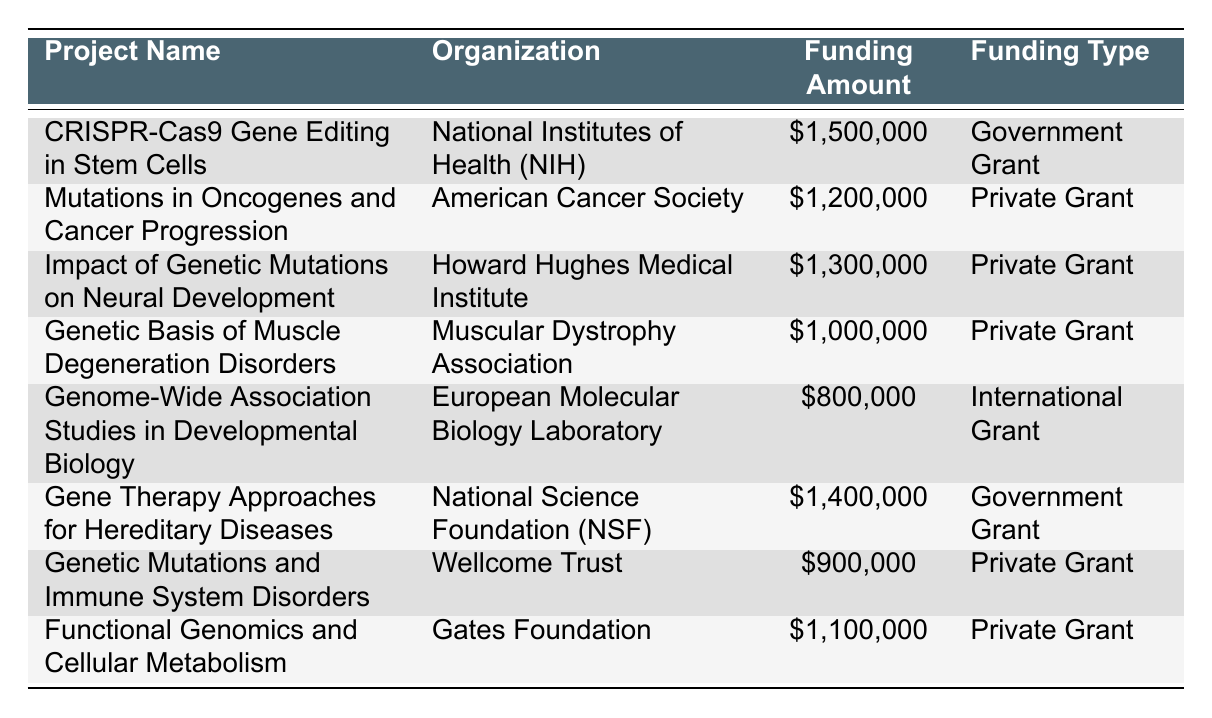What is the total funding allocated for projects by the National Institutes of Health? There is one project funded by the National Institutes of Health, which is "CRISPR-Cas9 Gene Editing in Stem Cells," with a funding amount of $1,500,000. Therefore, the total funding from NIH is $1,500,000.
Answer: $1,500,000 Which organization received the highest funding for a project? The project "CRISPR-Cas9 Gene Editing in Stem Cells" by the National Institutes of Health received the highest funding amount of $1,500,000 when compared to all other listed projects.
Answer: National Institutes of Health How much more funding was allocated to the "Impact of Genetic Mutations on Neural Development" compared to "Genetic Mutations and Immune System Disorders"? The funding for "Impact of Genetic Mutations on Neural Development" is $1,300,000, while "Genetic Mutations and Immune System Disorders" received $900,000. The difference is $1,300,000 - $900,000 = $400,000.
Answer: $400,000 Is there any project focusing on muscle degeneration disorders? Yes, the project "Genetic Basis of Muscle Degeneration Disorders" is listed, which indicates that there is a focus on muscle degeneration disorders.
Answer: Yes What is the average funding amount for private grant projects? There are five private grant projects: "Mutations in Oncogenes and Cancer Progression" ($1,200,000), "Impact of Genetic Mutations on Neural Development" ($1,300,000), "Genetic Basis of Muscle Degeneration Disorders" ($1,000,000), "Genetic Mutations and Immune System Disorders" ($900,000), and "Functional Genomics and Cellular Metabolism" ($1,100,000). The total for these is $1,200,000 + $1,300,000 + $1,000,000 + $900,000 + $1,100,000 = $5,500,000, and there are 5 projects, so the average is $5,500,000 / 5 = $1,100,000.
Answer: $1,100,000 Which funding type has the project with the least funding amount? The project with the least funding is "Genome-Wide Association Studies in Developmental Biology" with an amount of $800,000, which is associated with an International Grant.
Answer: International Grant 